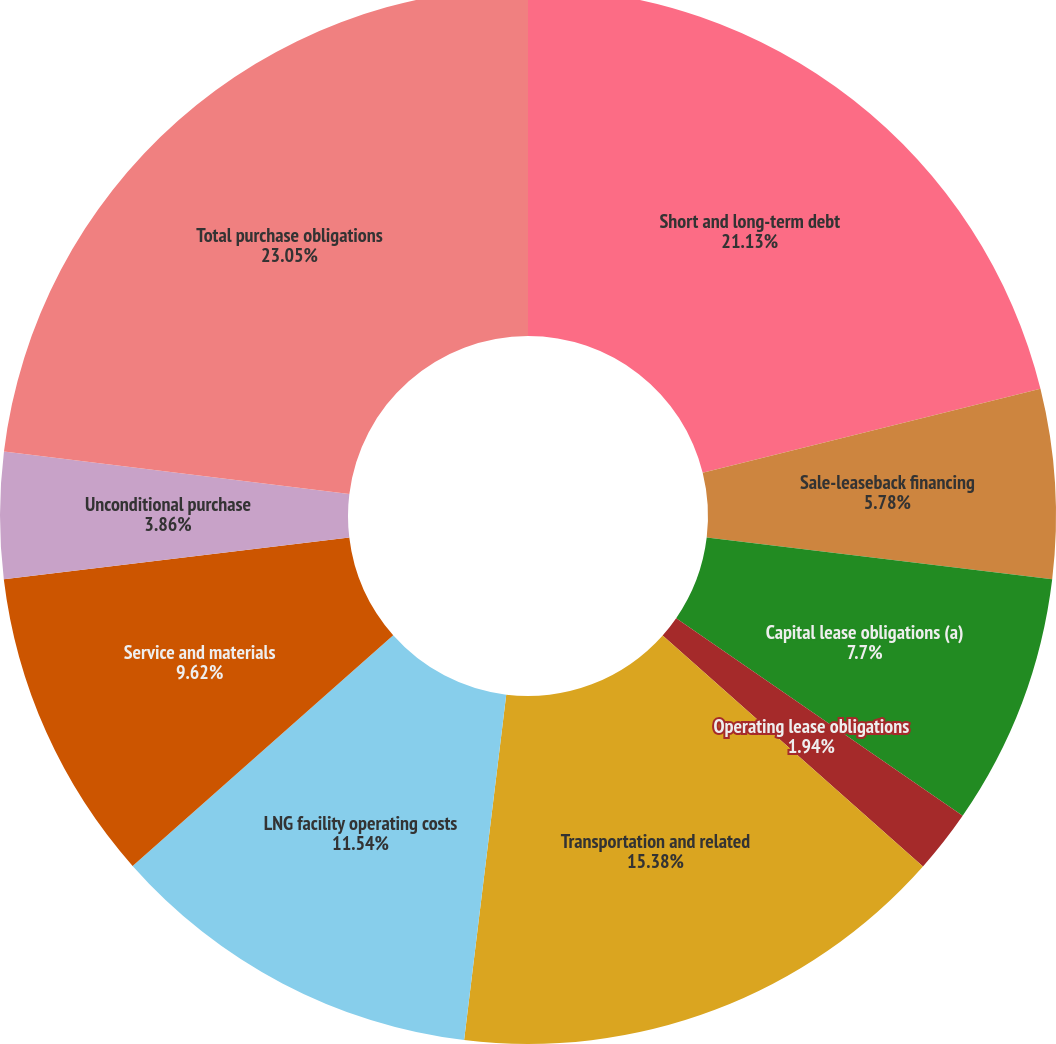<chart> <loc_0><loc_0><loc_500><loc_500><pie_chart><fcel>Short and long-term debt<fcel>Sale-leaseback financing<fcel>Capital lease obligations (a)<fcel>Operating lease obligations<fcel>Transportation and related<fcel>LNG facility operating costs<fcel>Service and materials<fcel>Unconditional purchase<fcel>Total purchase obligations<nl><fcel>21.13%<fcel>5.78%<fcel>7.7%<fcel>1.94%<fcel>15.38%<fcel>11.54%<fcel>9.62%<fcel>3.86%<fcel>23.05%<nl></chart> 